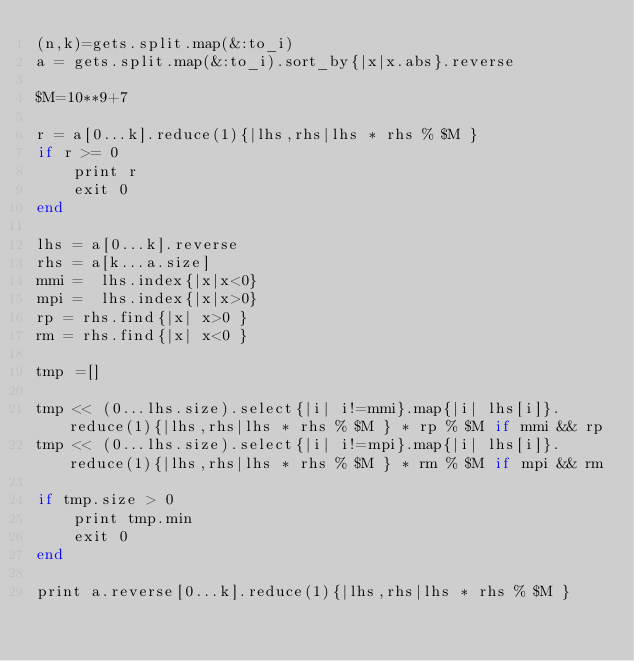<code> <loc_0><loc_0><loc_500><loc_500><_Ruby_>(n,k)=gets.split.map(&:to_i)
a = gets.split.map(&:to_i).sort_by{|x|x.abs}.reverse

$M=10**9+7

r = a[0...k].reduce(1){|lhs,rhs|lhs * rhs % $M }
if r >= 0
    print r
    exit 0
end

lhs = a[0...k].reverse
rhs = a[k...a.size]
mmi =  lhs.index{|x|x<0}
mpi =  lhs.index{|x|x>0}
rp = rhs.find{|x| x>0 }
rm = rhs.find{|x| x<0 }

tmp =[]

tmp << (0...lhs.size).select{|i| i!=mmi}.map{|i| lhs[i]}.reduce(1){|lhs,rhs|lhs * rhs % $M } * rp % $M if mmi && rp
tmp << (0...lhs.size).select{|i| i!=mpi}.map{|i| lhs[i]}.reduce(1){|lhs,rhs|lhs * rhs % $M } * rm % $M if mpi && rm

if tmp.size > 0
    print tmp.min 
    exit 0
end

print a.reverse[0...k].reduce(1){|lhs,rhs|lhs * rhs % $M }</code> 